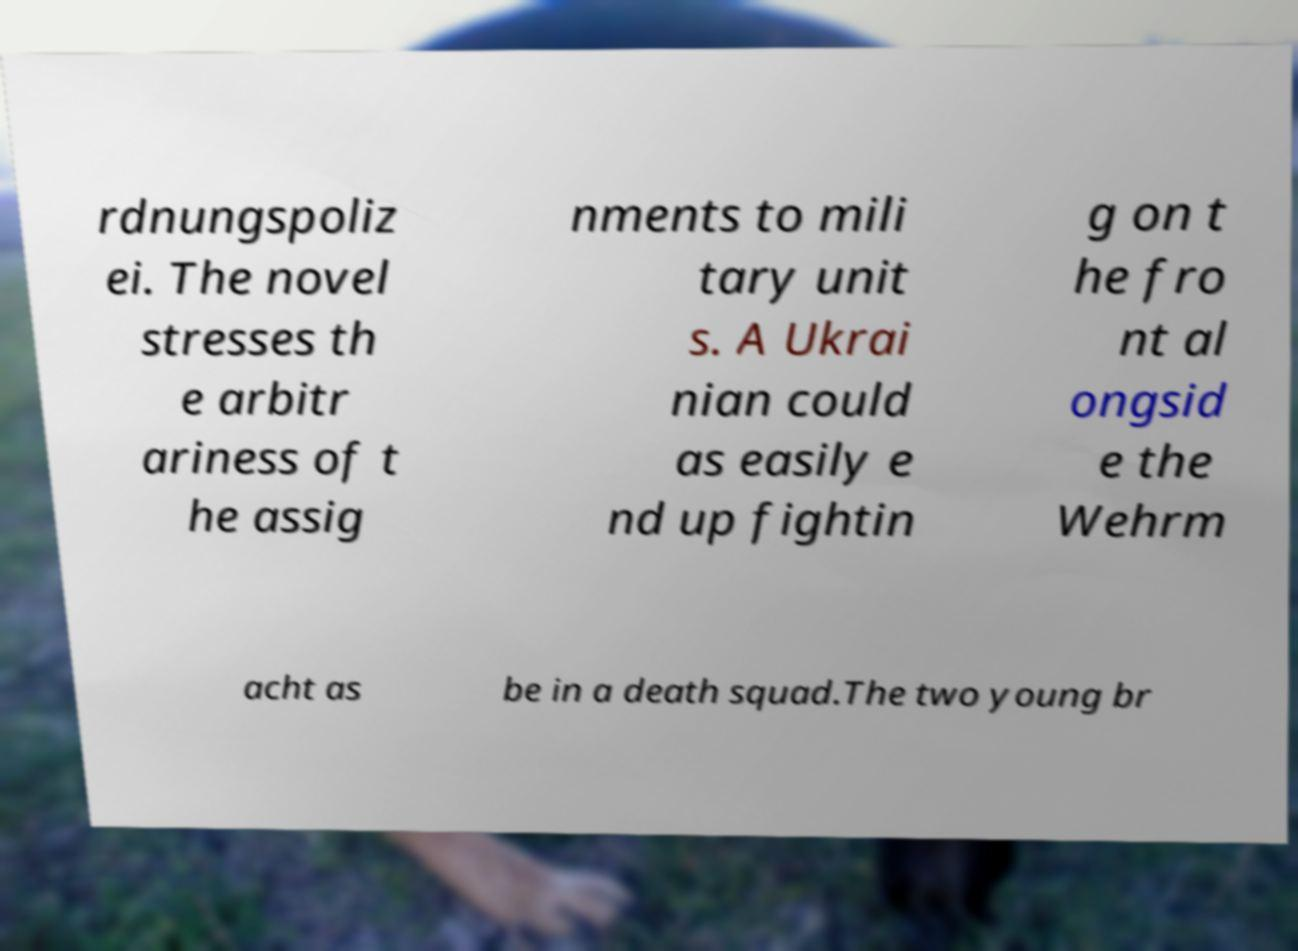Could you extract and type out the text from this image? rdnungspoliz ei. The novel stresses th e arbitr ariness of t he assig nments to mili tary unit s. A Ukrai nian could as easily e nd up fightin g on t he fro nt al ongsid e the Wehrm acht as be in a death squad.The two young br 